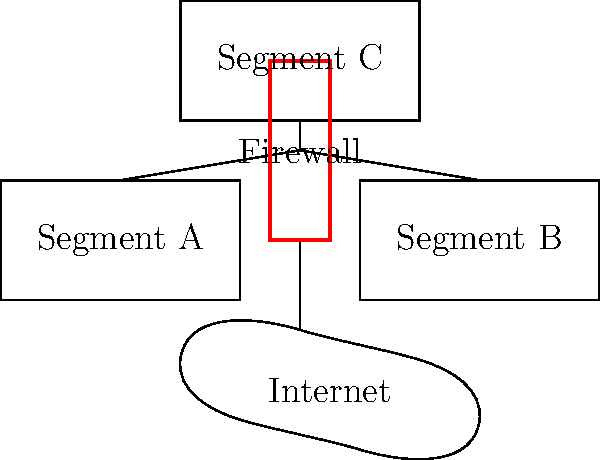As a computer programmer working for a software company, you've been tasked with setting up a firewall to protect specific network segments. Given the network diagram, which shows three segments (A, B, and C) connected through a central firewall to the internet, how would you configure the firewall rules to allow Segment A to access the internet, Segment B to access only Segment C, and Segment C to have no outside access? To configure the firewall rules for the given scenario, follow these steps:

1. Analyze the network layout:
   - Segment A needs internet access
   - Segment B needs access only to Segment C
   - Segment C should have no outside access

2. Configure rules for Segment A:
   - Allow outbound traffic from Segment A to the internet
   - Allow inbound traffic from the internet to Segment A only if it's part of an established connection

3. Configure rules for Segment B:
   - Block all outbound traffic from Segment B to the internet
   - Allow outbound traffic from Segment B to Segment C
   - Allow inbound traffic from Segment C to Segment B

4. Configure rules for Segment C:
   - Block all outbound traffic from Segment C to the internet
   - Allow inbound traffic from Segment B to Segment C
   - Block all other inbound traffic to Segment C

5. Set up general firewall policies:
   - Set the default policy to "deny all" for both inbound and outbound traffic
   - Implement rules in order from most specific to most general

6. Implement logging and monitoring:
   - Enable logging for all blocked traffic attempts
   - Set up alerts for suspicious activity or repeated access attempts

By following these steps, you create a secure environment where:
- Segment A can access the internet but is protected from unsolicited inbound connections
- Segment B can only communicate with Segment C
- Segment C is isolated from the internet and can only receive traffic from Segment B
Answer: Allow Segment A internet access, Segment B to Segment C only, block Segment C external access. 